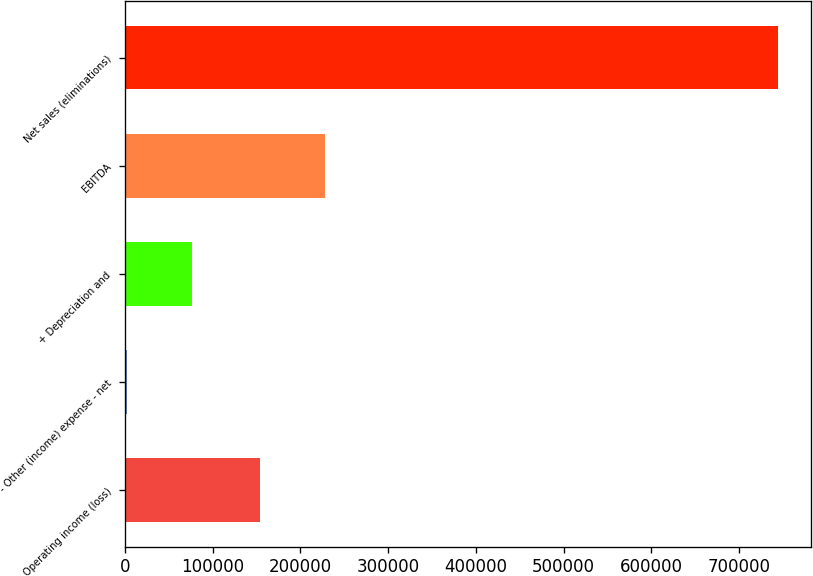Convert chart. <chart><loc_0><loc_0><loc_500><loc_500><bar_chart><fcel>Operating income (loss)<fcel>- Other (income) expense - net<fcel>+ Depreciation and<fcel>EBITDA<fcel>Net sales (eliminations)<nl><fcel>153691<fcel>1991<fcel>76272.8<fcel>227973<fcel>744809<nl></chart> 